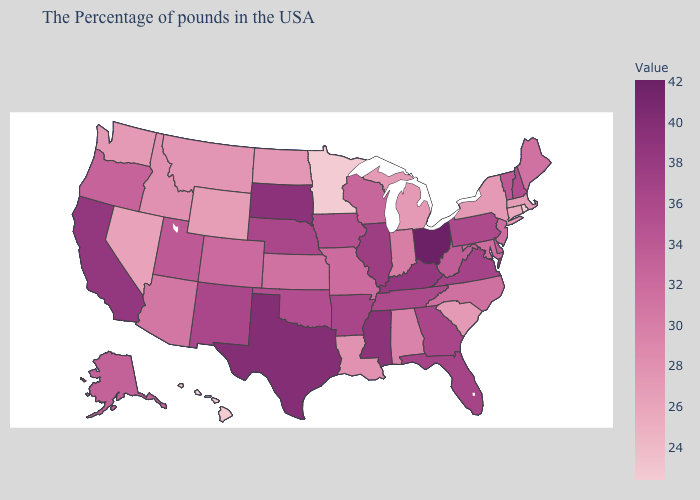Does Iowa have the lowest value in the USA?
Answer briefly. No. Among the states that border Texas , does Oklahoma have the lowest value?
Concise answer only. No. Which states have the lowest value in the USA?
Keep it brief. Rhode Island, Minnesota, Hawaii. Which states have the lowest value in the MidWest?
Answer briefly. Minnesota. Is the legend a continuous bar?
Quick response, please. Yes. Is the legend a continuous bar?
Concise answer only. Yes. Does the map have missing data?
Concise answer only. No. 